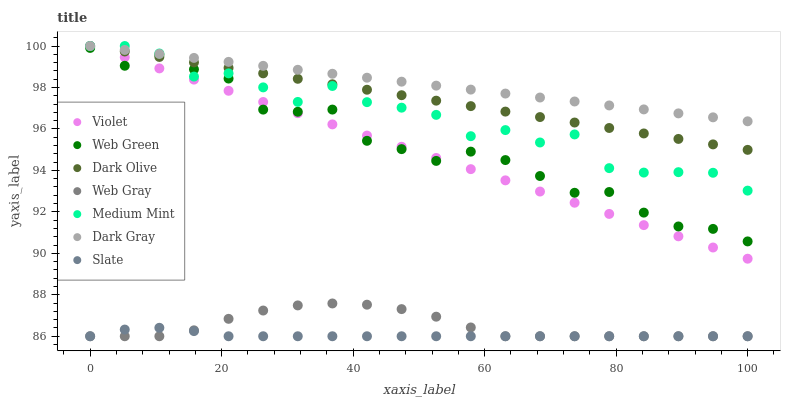Does Slate have the minimum area under the curve?
Answer yes or no. Yes. Does Dark Gray have the maximum area under the curve?
Answer yes or no. Yes. Does Web Gray have the minimum area under the curve?
Answer yes or no. No. Does Web Gray have the maximum area under the curve?
Answer yes or no. No. Is Dark Gray the smoothest?
Answer yes or no. Yes. Is Medium Mint the roughest?
Answer yes or no. Yes. Is Web Gray the smoothest?
Answer yes or no. No. Is Web Gray the roughest?
Answer yes or no. No. Does Web Gray have the lowest value?
Answer yes or no. Yes. Does Dark Olive have the lowest value?
Answer yes or no. No. Does Violet have the highest value?
Answer yes or no. Yes. Does Web Gray have the highest value?
Answer yes or no. No. Is Web Green less than Dark Gray?
Answer yes or no. Yes. Is Violet greater than Web Gray?
Answer yes or no. Yes. Does Dark Gray intersect Dark Olive?
Answer yes or no. Yes. Is Dark Gray less than Dark Olive?
Answer yes or no. No. Is Dark Gray greater than Dark Olive?
Answer yes or no. No. Does Web Green intersect Dark Gray?
Answer yes or no. No. 